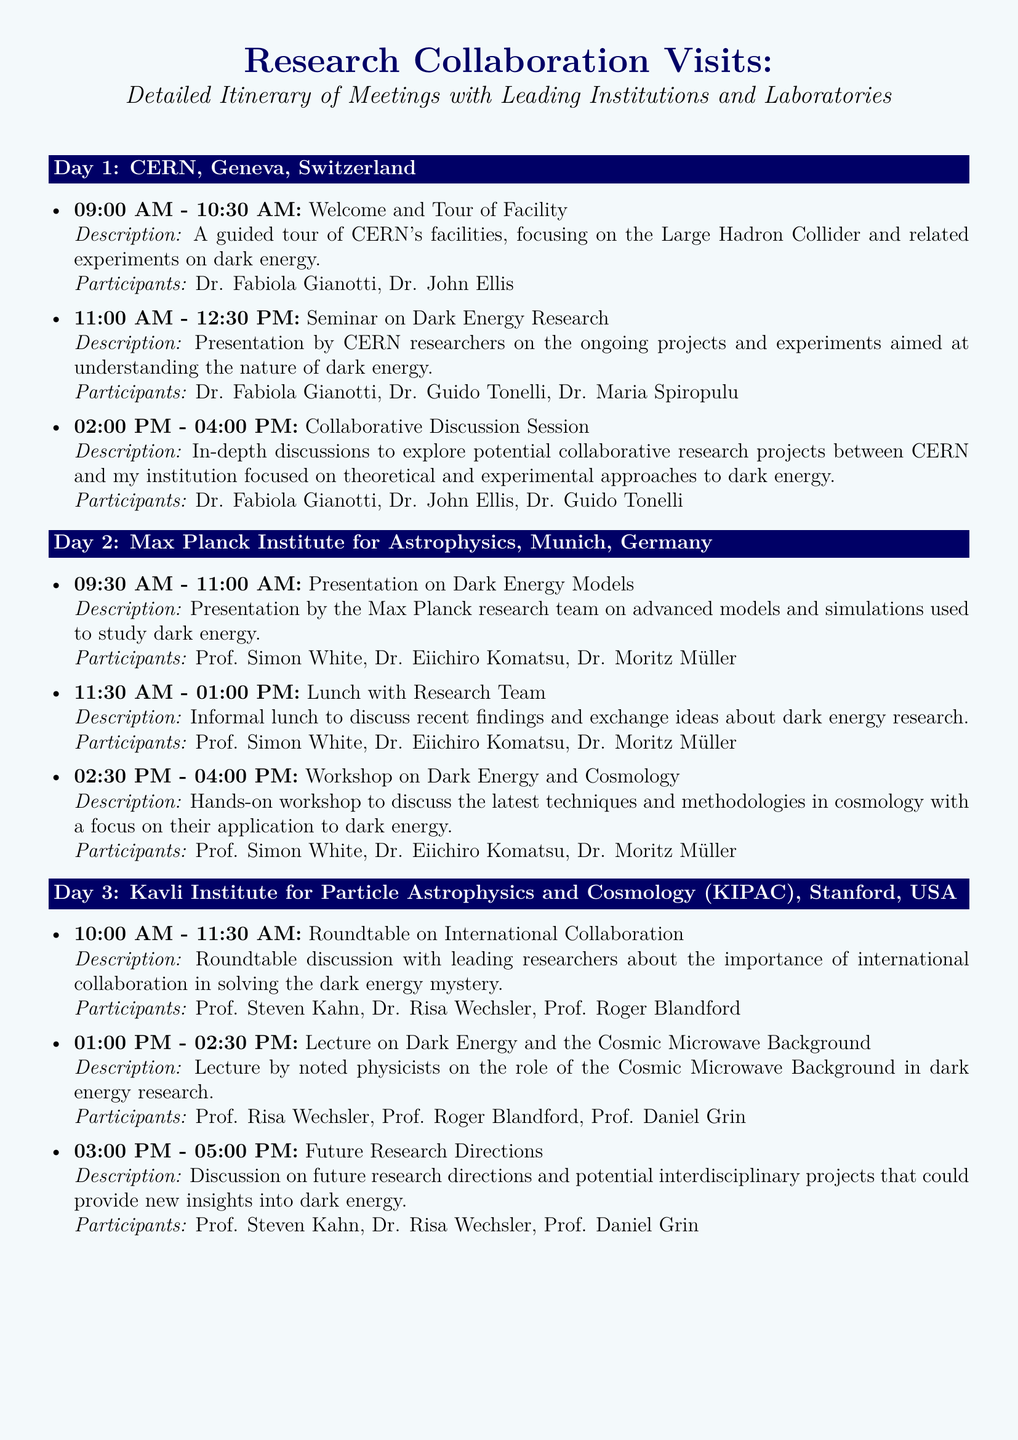What is the first meeting's time at CERN? The first meeting is scheduled for 09:00 AM on Day 1 at CERN.
Answer: 09:00 AM Who is the main speaker at the seminar on dark energy research? The main speaker at this seminar is Dr. Fabiola Gianotti.
Answer: Dr. Fabiola Gianotti What institution is hosting Day 2 of the itinerary? The itinerary for Day 2 is hosted at the Max Planck Institute for Astrophysics.
Answer: Max Planck Institute for Astrophysics How long does the workshop on dark energy and cosmology last? The workshop on dark energy and cosmology is scheduled for 1.5 hours, from 02:30 PM to 04:00 PM.
Answer: 1.5 hours What is the focus of the roundtable discussion on Day 3? The roundtable discussion focuses on the importance of international collaboration in solving the dark energy mystery.
Answer: International collaboration List one of the participants in the future research directions discussion. One of the participants in the discussion is Prof. Daniel Grin.
Answer: Prof. Daniel Grin What time does the presentation on dark energy models begin? The presentation on dark energy models begins at 09:30 AM on Day 2.
Answer: 09:30 AM How many meetings are scheduled on Day 1? There are three meetings scheduled on Day 1 at CERN.
Answer: Three meetings What description is provided for the collaborative discussion session? The session's description mentions in-depth discussions to explore potential collaborative research projects.
Answer: In-depth discussions to explore potential collaborative research projects 